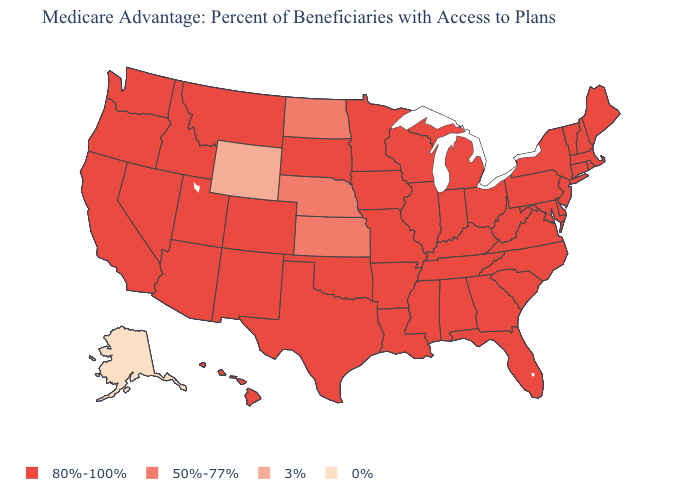Does Idaho have the lowest value in the USA?
Write a very short answer. No. Name the states that have a value in the range 80%-100%?
Answer briefly. Alabama, Arizona, Arkansas, California, Colorado, Connecticut, Delaware, Florida, Georgia, Hawaii, Idaho, Illinois, Indiana, Iowa, Kentucky, Louisiana, Maine, Maryland, Massachusetts, Michigan, Minnesota, Mississippi, Missouri, Montana, Nevada, New Hampshire, New Jersey, New Mexico, New York, North Carolina, Ohio, Oklahoma, Oregon, Pennsylvania, Rhode Island, South Carolina, South Dakota, Tennessee, Texas, Utah, Vermont, Virginia, Washington, West Virginia, Wisconsin. Is the legend a continuous bar?
Be succinct. No. How many symbols are there in the legend?
Keep it brief. 4. What is the value of Hawaii?
Answer briefly. 80%-100%. Does Texas have the same value as Oregon?
Short answer required. Yes. Does Mississippi have the same value as Washington?
Give a very brief answer. Yes. What is the value of Wyoming?
Give a very brief answer. 3%. What is the value of West Virginia?
Be succinct. 80%-100%. What is the highest value in the MidWest ?
Answer briefly. 80%-100%. Does Oregon have a lower value than Wisconsin?
Give a very brief answer. No. What is the value of Arizona?
Quick response, please. 80%-100%. What is the value of Missouri?
Keep it brief. 80%-100%. Name the states that have a value in the range 50%-77%?
Quick response, please. Kansas, Nebraska, North Dakota. 